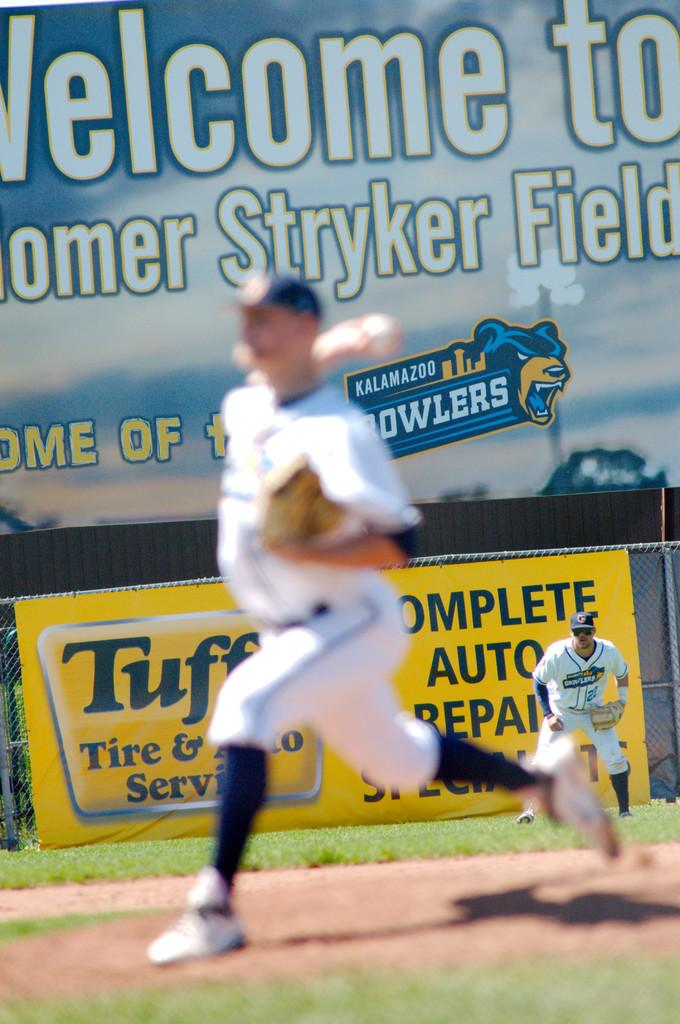<image>
Summarize the visual content of the image. A pitcher is seen in front of an advertisement for complete auto repair. 